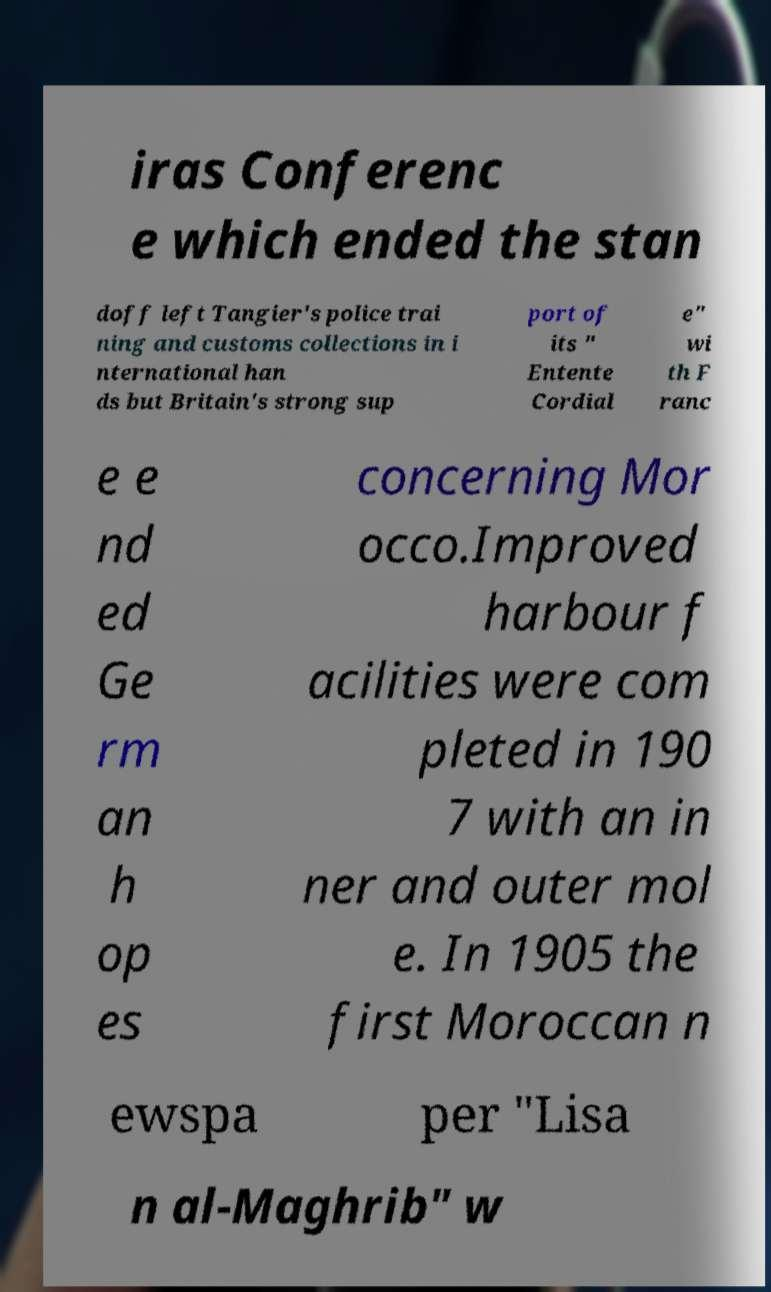I need the written content from this picture converted into text. Can you do that? iras Conferenc e which ended the stan doff left Tangier's police trai ning and customs collections in i nternational han ds but Britain's strong sup port of its " Entente Cordial e" wi th F ranc e e nd ed Ge rm an h op es concerning Mor occo.Improved harbour f acilities were com pleted in 190 7 with an in ner and outer mol e. In 1905 the first Moroccan n ewspa per "Lisa n al-Maghrib" w 